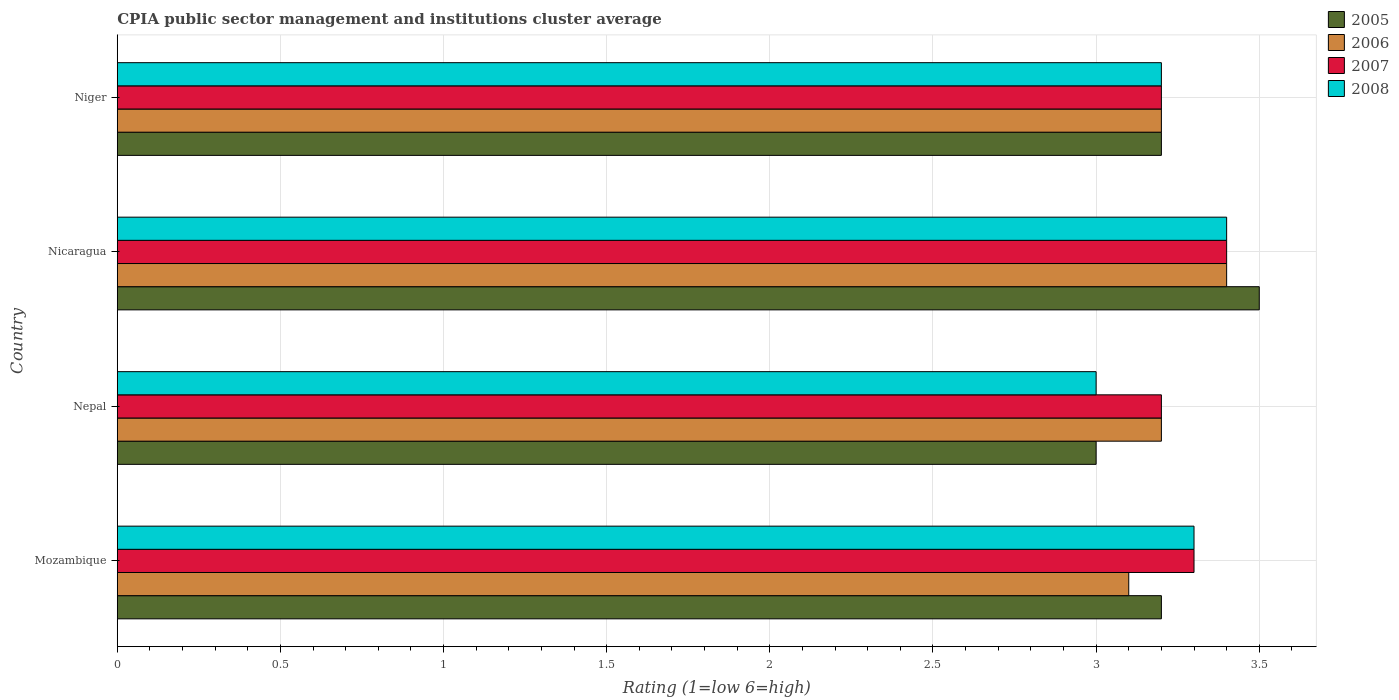How many different coloured bars are there?
Ensure brevity in your answer.  4. Are the number of bars on each tick of the Y-axis equal?
Your response must be concise. Yes. How many bars are there on the 4th tick from the bottom?
Your answer should be compact. 4. What is the label of the 2nd group of bars from the top?
Your answer should be compact. Nicaragua. Across all countries, what is the minimum CPIA rating in 2005?
Your answer should be compact. 3. In which country was the CPIA rating in 2005 maximum?
Your answer should be compact. Nicaragua. In which country was the CPIA rating in 2008 minimum?
Provide a succinct answer. Nepal. What is the total CPIA rating in 2008 in the graph?
Your answer should be compact. 12.9. What is the difference between the CPIA rating in 2006 in Mozambique and that in Nepal?
Provide a short and direct response. -0.1. What is the average CPIA rating in 2008 per country?
Offer a very short reply. 3.22. In how many countries, is the CPIA rating in 2007 greater than 3.1 ?
Offer a terse response. 4. What is the ratio of the CPIA rating in 2005 in Mozambique to that in Nicaragua?
Keep it short and to the point. 0.91. What is the difference between the highest and the second highest CPIA rating in 2007?
Provide a short and direct response. 0.1. What is the difference between the highest and the lowest CPIA rating in 2006?
Provide a short and direct response. 0.3. In how many countries, is the CPIA rating in 2007 greater than the average CPIA rating in 2007 taken over all countries?
Make the answer very short. 2. Is the sum of the CPIA rating in 2007 in Mozambique and Niger greater than the maximum CPIA rating in 2006 across all countries?
Give a very brief answer. Yes. What does the 1st bar from the top in Niger represents?
Your response must be concise. 2008. Is it the case that in every country, the sum of the CPIA rating in 2006 and CPIA rating in 2005 is greater than the CPIA rating in 2007?
Your answer should be very brief. Yes. What is the difference between two consecutive major ticks on the X-axis?
Your response must be concise. 0.5. Does the graph contain any zero values?
Provide a succinct answer. No. Where does the legend appear in the graph?
Give a very brief answer. Top right. What is the title of the graph?
Your response must be concise. CPIA public sector management and institutions cluster average. Does "1985" appear as one of the legend labels in the graph?
Keep it short and to the point. No. What is the label or title of the Y-axis?
Provide a short and direct response. Country. What is the Rating (1=low 6=high) of 2005 in Mozambique?
Your answer should be compact. 3.2. What is the Rating (1=low 6=high) of 2006 in Mozambique?
Offer a terse response. 3.1. What is the Rating (1=low 6=high) of 2007 in Mozambique?
Offer a terse response. 3.3. What is the Rating (1=low 6=high) of 2008 in Mozambique?
Give a very brief answer. 3.3. What is the Rating (1=low 6=high) in 2006 in Nepal?
Give a very brief answer. 3.2. What is the Rating (1=low 6=high) in 2007 in Niger?
Offer a terse response. 3.2. What is the Rating (1=low 6=high) of 2008 in Niger?
Make the answer very short. 3.2. Across all countries, what is the maximum Rating (1=low 6=high) of 2006?
Ensure brevity in your answer.  3.4. Across all countries, what is the minimum Rating (1=low 6=high) in 2005?
Your answer should be compact. 3. Across all countries, what is the minimum Rating (1=low 6=high) in 2007?
Your answer should be compact. 3.2. What is the total Rating (1=low 6=high) in 2005 in the graph?
Offer a terse response. 12.9. What is the difference between the Rating (1=low 6=high) of 2005 in Mozambique and that in Nepal?
Keep it short and to the point. 0.2. What is the difference between the Rating (1=low 6=high) in 2006 in Mozambique and that in Nepal?
Keep it short and to the point. -0.1. What is the difference between the Rating (1=low 6=high) of 2007 in Mozambique and that in Nepal?
Keep it short and to the point. 0.1. What is the difference between the Rating (1=low 6=high) in 2008 in Mozambique and that in Nicaragua?
Offer a terse response. -0.1. What is the difference between the Rating (1=low 6=high) of 2006 in Mozambique and that in Niger?
Your answer should be compact. -0.1. What is the difference between the Rating (1=low 6=high) in 2005 in Nepal and that in Niger?
Offer a terse response. -0.2. What is the difference between the Rating (1=low 6=high) in 2006 in Nepal and that in Niger?
Offer a terse response. 0. What is the difference between the Rating (1=low 6=high) in 2008 in Nepal and that in Niger?
Offer a very short reply. -0.2. What is the difference between the Rating (1=low 6=high) in 2005 in Nicaragua and that in Niger?
Your answer should be compact. 0.3. What is the difference between the Rating (1=low 6=high) of 2006 in Nicaragua and that in Niger?
Offer a very short reply. 0.2. What is the difference between the Rating (1=low 6=high) of 2007 in Nicaragua and that in Niger?
Offer a very short reply. 0.2. What is the difference between the Rating (1=low 6=high) in 2008 in Nicaragua and that in Niger?
Offer a terse response. 0.2. What is the difference between the Rating (1=low 6=high) in 2005 in Mozambique and the Rating (1=low 6=high) in 2007 in Nepal?
Your response must be concise. 0. What is the difference between the Rating (1=low 6=high) in 2006 in Mozambique and the Rating (1=low 6=high) in 2007 in Nepal?
Offer a very short reply. -0.1. What is the difference between the Rating (1=low 6=high) of 2006 in Mozambique and the Rating (1=low 6=high) of 2008 in Nepal?
Give a very brief answer. 0.1. What is the difference between the Rating (1=low 6=high) of 2007 in Mozambique and the Rating (1=low 6=high) of 2008 in Nepal?
Ensure brevity in your answer.  0.3. What is the difference between the Rating (1=low 6=high) in 2005 in Mozambique and the Rating (1=low 6=high) in 2006 in Nicaragua?
Keep it short and to the point. -0.2. What is the difference between the Rating (1=low 6=high) of 2005 in Mozambique and the Rating (1=low 6=high) of 2007 in Nicaragua?
Provide a short and direct response. -0.2. What is the difference between the Rating (1=low 6=high) of 2006 in Mozambique and the Rating (1=low 6=high) of 2007 in Nicaragua?
Offer a terse response. -0.3. What is the difference between the Rating (1=low 6=high) of 2006 in Mozambique and the Rating (1=low 6=high) of 2008 in Nicaragua?
Provide a succinct answer. -0.3. What is the difference between the Rating (1=low 6=high) of 2007 in Mozambique and the Rating (1=low 6=high) of 2008 in Nicaragua?
Provide a short and direct response. -0.1. What is the difference between the Rating (1=low 6=high) in 2005 in Mozambique and the Rating (1=low 6=high) in 2006 in Niger?
Offer a very short reply. 0. What is the difference between the Rating (1=low 6=high) in 2005 in Mozambique and the Rating (1=low 6=high) in 2008 in Niger?
Provide a short and direct response. 0. What is the difference between the Rating (1=low 6=high) of 2006 in Mozambique and the Rating (1=low 6=high) of 2007 in Niger?
Keep it short and to the point. -0.1. What is the difference between the Rating (1=low 6=high) of 2006 in Mozambique and the Rating (1=low 6=high) of 2008 in Niger?
Provide a short and direct response. -0.1. What is the difference between the Rating (1=low 6=high) of 2005 in Nepal and the Rating (1=low 6=high) of 2006 in Nicaragua?
Make the answer very short. -0.4. What is the difference between the Rating (1=low 6=high) of 2006 in Nepal and the Rating (1=low 6=high) of 2007 in Nicaragua?
Provide a succinct answer. -0.2. What is the difference between the Rating (1=low 6=high) in 2006 in Nepal and the Rating (1=low 6=high) in 2008 in Nicaragua?
Offer a terse response. -0.2. What is the difference between the Rating (1=low 6=high) of 2006 in Nepal and the Rating (1=low 6=high) of 2007 in Niger?
Offer a very short reply. 0. What is the difference between the Rating (1=low 6=high) of 2005 in Nicaragua and the Rating (1=low 6=high) of 2006 in Niger?
Offer a very short reply. 0.3. What is the difference between the Rating (1=low 6=high) of 2006 in Nicaragua and the Rating (1=low 6=high) of 2007 in Niger?
Ensure brevity in your answer.  0.2. What is the difference between the Rating (1=low 6=high) in 2006 in Nicaragua and the Rating (1=low 6=high) in 2008 in Niger?
Your response must be concise. 0.2. What is the average Rating (1=low 6=high) of 2005 per country?
Your answer should be compact. 3.23. What is the average Rating (1=low 6=high) in 2006 per country?
Ensure brevity in your answer.  3.23. What is the average Rating (1=low 6=high) in 2007 per country?
Make the answer very short. 3.27. What is the average Rating (1=low 6=high) of 2008 per country?
Keep it short and to the point. 3.23. What is the difference between the Rating (1=low 6=high) of 2006 and Rating (1=low 6=high) of 2008 in Mozambique?
Make the answer very short. -0.2. What is the difference between the Rating (1=low 6=high) of 2007 and Rating (1=low 6=high) of 2008 in Mozambique?
Make the answer very short. 0. What is the difference between the Rating (1=low 6=high) of 2005 and Rating (1=low 6=high) of 2006 in Nepal?
Keep it short and to the point. -0.2. What is the difference between the Rating (1=low 6=high) of 2005 and Rating (1=low 6=high) of 2008 in Nepal?
Keep it short and to the point. 0. What is the difference between the Rating (1=low 6=high) in 2006 and Rating (1=low 6=high) in 2008 in Nepal?
Your response must be concise. 0.2. What is the difference between the Rating (1=low 6=high) of 2005 and Rating (1=low 6=high) of 2007 in Nicaragua?
Provide a succinct answer. 0.1. What is the difference between the Rating (1=low 6=high) in 2005 and Rating (1=low 6=high) in 2007 in Niger?
Give a very brief answer. 0. What is the difference between the Rating (1=low 6=high) in 2005 and Rating (1=low 6=high) in 2008 in Niger?
Your response must be concise. 0. What is the difference between the Rating (1=low 6=high) in 2006 and Rating (1=low 6=high) in 2007 in Niger?
Make the answer very short. 0. What is the difference between the Rating (1=low 6=high) in 2006 and Rating (1=low 6=high) in 2008 in Niger?
Provide a short and direct response. 0. What is the difference between the Rating (1=low 6=high) in 2007 and Rating (1=low 6=high) in 2008 in Niger?
Your answer should be very brief. 0. What is the ratio of the Rating (1=low 6=high) in 2005 in Mozambique to that in Nepal?
Give a very brief answer. 1.07. What is the ratio of the Rating (1=low 6=high) in 2006 in Mozambique to that in Nepal?
Offer a terse response. 0.97. What is the ratio of the Rating (1=low 6=high) of 2007 in Mozambique to that in Nepal?
Offer a very short reply. 1.03. What is the ratio of the Rating (1=low 6=high) in 2008 in Mozambique to that in Nepal?
Your response must be concise. 1.1. What is the ratio of the Rating (1=low 6=high) of 2005 in Mozambique to that in Nicaragua?
Your response must be concise. 0.91. What is the ratio of the Rating (1=low 6=high) of 2006 in Mozambique to that in Nicaragua?
Your answer should be very brief. 0.91. What is the ratio of the Rating (1=low 6=high) in 2007 in Mozambique to that in Nicaragua?
Your answer should be compact. 0.97. What is the ratio of the Rating (1=low 6=high) in 2008 in Mozambique to that in Nicaragua?
Offer a very short reply. 0.97. What is the ratio of the Rating (1=low 6=high) of 2005 in Mozambique to that in Niger?
Your answer should be very brief. 1. What is the ratio of the Rating (1=low 6=high) in 2006 in Mozambique to that in Niger?
Ensure brevity in your answer.  0.97. What is the ratio of the Rating (1=low 6=high) of 2007 in Mozambique to that in Niger?
Offer a terse response. 1.03. What is the ratio of the Rating (1=low 6=high) in 2008 in Mozambique to that in Niger?
Provide a short and direct response. 1.03. What is the ratio of the Rating (1=low 6=high) in 2006 in Nepal to that in Nicaragua?
Your answer should be very brief. 0.94. What is the ratio of the Rating (1=low 6=high) of 2007 in Nepal to that in Nicaragua?
Offer a terse response. 0.94. What is the ratio of the Rating (1=low 6=high) of 2008 in Nepal to that in Nicaragua?
Offer a very short reply. 0.88. What is the ratio of the Rating (1=low 6=high) in 2006 in Nepal to that in Niger?
Offer a very short reply. 1. What is the ratio of the Rating (1=low 6=high) in 2008 in Nepal to that in Niger?
Your answer should be very brief. 0.94. What is the ratio of the Rating (1=low 6=high) of 2005 in Nicaragua to that in Niger?
Make the answer very short. 1.09. What is the difference between the highest and the second highest Rating (1=low 6=high) of 2007?
Offer a terse response. 0.1. What is the difference between the highest and the lowest Rating (1=low 6=high) in 2005?
Offer a terse response. 0.5. What is the difference between the highest and the lowest Rating (1=low 6=high) of 2006?
Give a very brief answer. 0.3. 